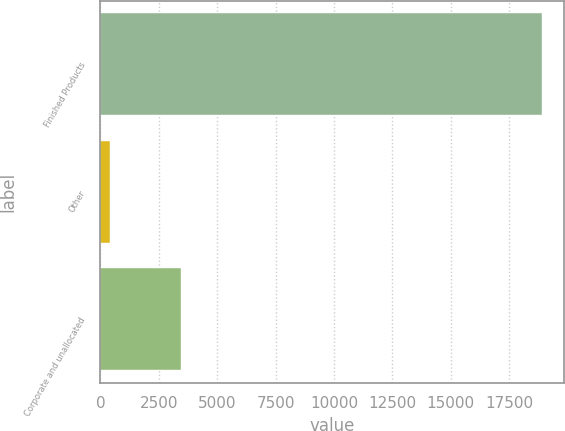<chart> <loc_0><loc_0><loc_500><loc_500><bar_chart><fcel>Finished Products<fcel>Other<fcel>Corporate and unallocated<nl><fcel>18888<fcel>423<fcel>3451<nl></chart> 